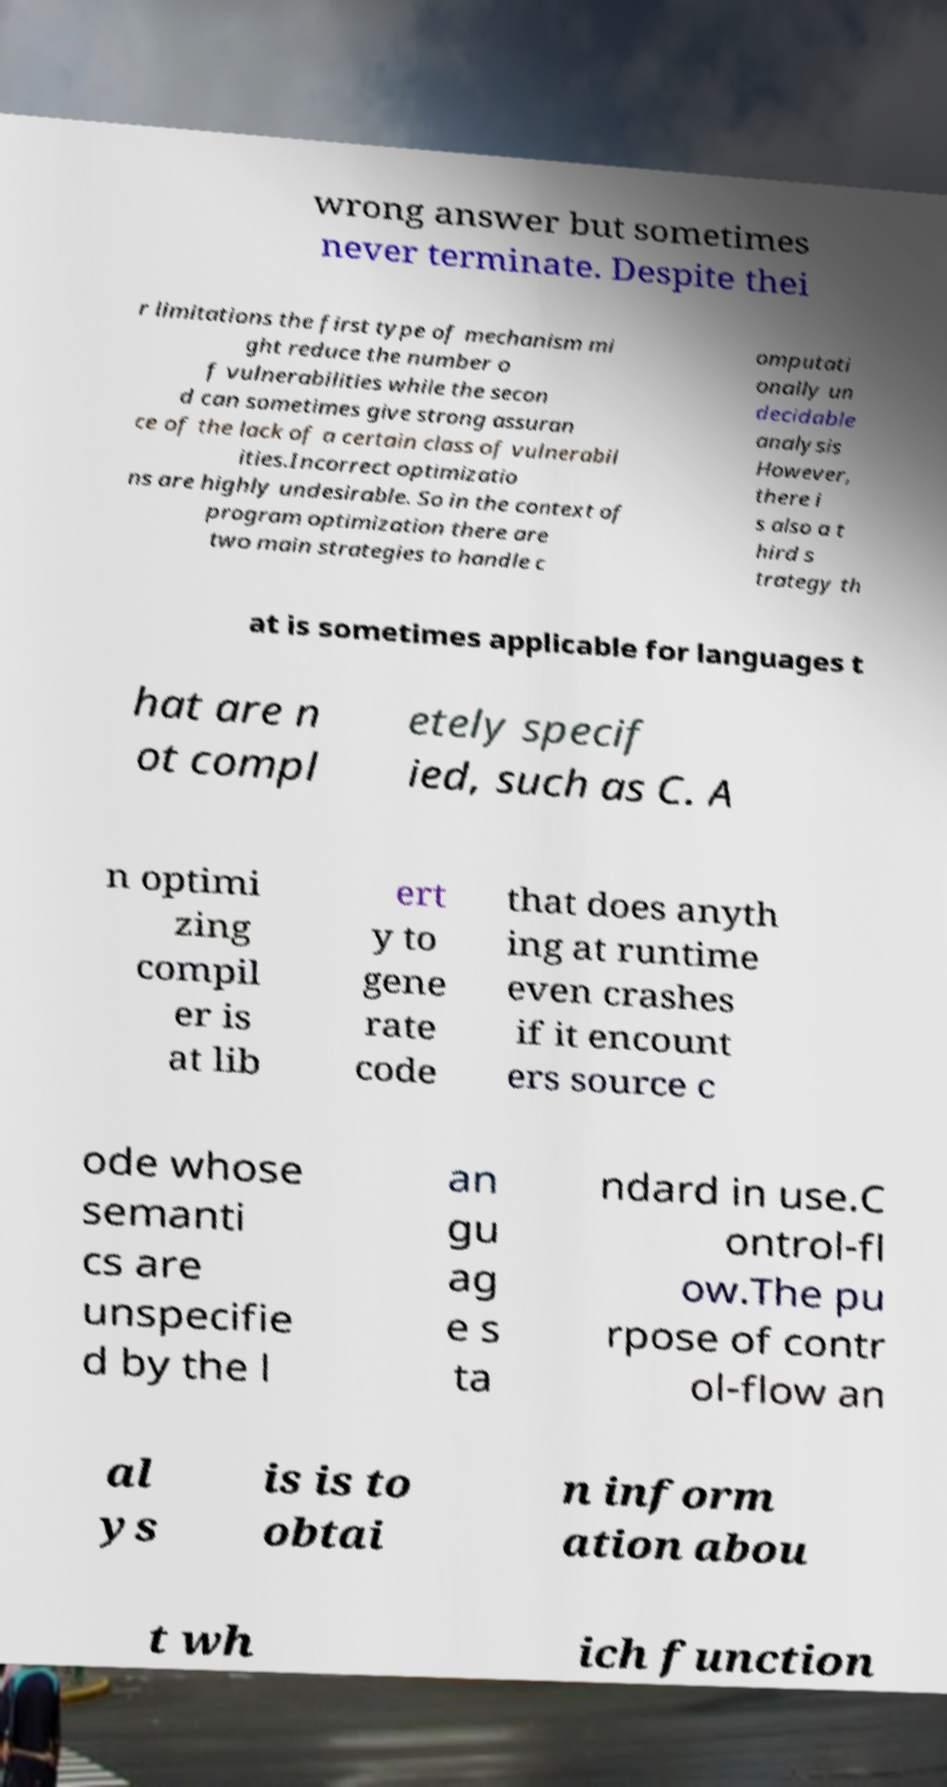Please read and relay the text visible in this image. What does it say? wrong answer but sometimes never terminate. Despite thei r limitations the first type of mechanism mi ght reduce the number o f vulnerabilities while the secon d can sometimes give strong assuran ce of the lack of a certain class of vulnerabil ities.Incorrect optimizatio ns are highly undesirable. So in the context of program optimization there are two main strategies to handle c omputati onally un decidable analysis However, there i s also a t hird s trategy th at is sometimes applicable for languages t hat are n ot compl etely specif ied, such as C. A n optimi zing compil er is at lib ert y to gene rate code that does anyth ing at runtime even crashes if it encount ers source c ode whose semanti cs are unspecifie d by the l an gu ag e s ta ndard in use.C ontrol-fl ow.The pu rpose of contr ol-flow an al ys is is to obtai n inform ation abou t wh ich function 